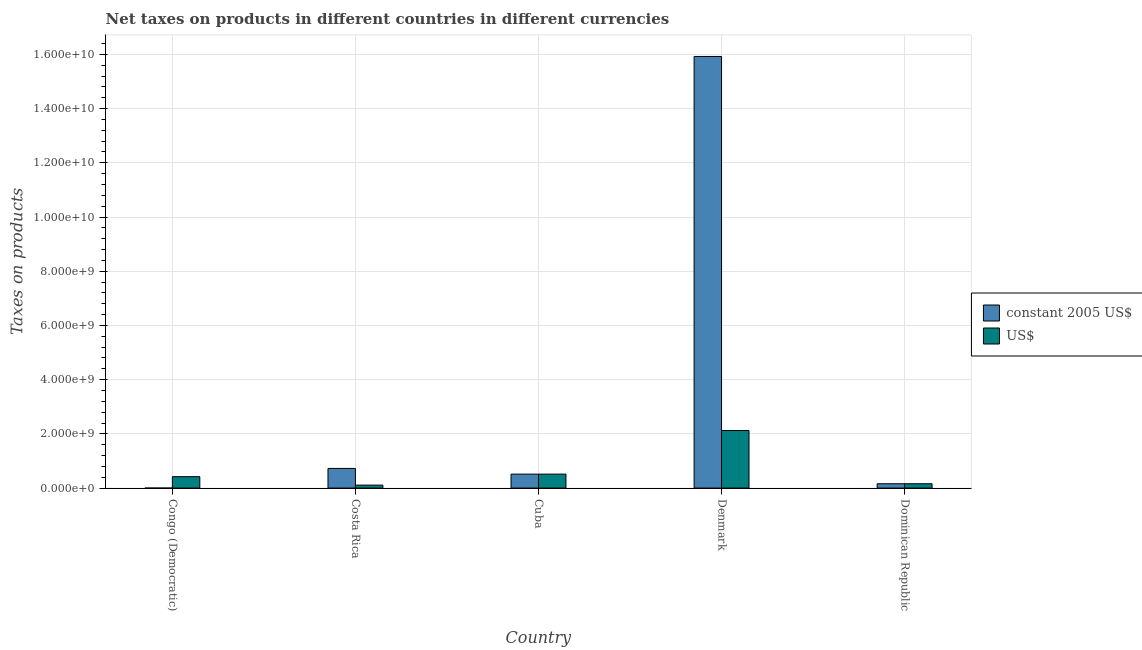What is the label of the 1st group of bars from the left?
Your response must be concise. Congo (Democratic). What is the net taxes in constant 2005 us$ in Denmark?
Offer a very short reply. 1.59e+1. Across all countries, what is the maximum net taxes in us$?
Your answer should be very brief. 2.12e+09. Across all countries, what is the minimum net taxes in us$?
Give a very brief answer. 1.09e+08. In which country was the net taxes in constant 2005 us$ maximum?
Offer a terse response. Denmark. What is the total net taxes in constant 2005 us$ in the graph?
Your answer should be very brief. 1.73e+1. What is the difference between the net taxes in constant 2005 us$ in Congo (Democratic) and that in Dominican Republic?
Offer a terse response. -1.60e+08. What is the difference between the net taxes in constant 2005 us$ in Denmark and the net taxes in us$ in Dominican Republic?
Keep it short and to the point. 1.58e+1. What is the average net taxes in constant 2005 us$ per country?
Ensure brevity in your answer.  3.47e+09. What is the difference between the net taxes in us$ and net taxes in constant 2005 us$ in Congo (Democratic)?
Provide a short and direct response. 4.22e+08. In how many countries, is the net taxes in us$ greater than 14800000000 units?
Provide a short and direct response. 0. What is the ratio of the net taxes in constant 2005 us$ in Congo (Democratic) to that in Costa Rica?
Your answer should be very brief. 9.713136937502124e-13. What is the difference between the highest and the second highest net taxes in us$?
Your answer should be compact. 1.61e+09. What is the difference between the highest and the lowest net taxes in constant 2005 us$?
Provide a succinct answer. 1.59e+1. In how many countries, is the net taxes in constant 2005 us$ greater than the average net taxes in constant 2005 us$ taken over all countries?
Keep it short and to the point. 1. What does the 2nd bar from the left in Cuba represents?
Give a very brief answer. US$. What does the 1st bar from the right in Cuba represents?
Offer a terse response. US$. Are all the bars in the graph horizontal?
Offer a terse response. No. What is the difference between two consecutive major ticks on the Y-axis?
Keep it short and to the point. 2.00e+09. Are the values on the major ticks of Y-axis written in scientific E-notation?
Keep it short and to the point. Yes. Where does the legend appear in the graph?
Keep it short and to the point. Center right. What is the title of the graph?
Your answer should be compact. Net taxes on products in different countries in different currencies. Does "External balance on goods" appear as one of the legend labels in the graph?
Offer a terse response. No. What is the label or title of the Y-axis?
Make the answer very short. Taxes on products. What is the Taxes on products in constant 2005 US$ in Congo (Democratic)?
Offer a terse response. 0. What is the Taxes on products in US$ in Congo (Democratic)?
Provide a succinct answer. 4.22e+08. What is the Taxes on products of constant 2005 US$ in Costa Rica?
Your answer should be very brief. 7.25e+08. What is the Taxes on products of US$ in Costa Rica?
Make the answer very short. 1.09e+08. What is the Taxes on products of constant 2005 US$ in Cuba?
Ensure brevity in your answer.  5.16e+08. What is the Taxes on products of US$ in Cuba?
Ensure brevity in your answer.  5.16e+08. What is the Taxes on products of constant 2005 US$ in Denmark?
Offer a very short reply. 1.59e+1. What is the Taxes on products in US$ in Denmark?
Offer a terse response. 2.12e+09. What is the Taxes on products of constant 2005 US$ in Dominican Republic?
Ensure brevity in your answer.  1.60e+08. What is the Taxes on products in US$ in Dominican Republic?
Your response must be concise. 1.60e+08. Across all countries, what is the maximum Taxes on products in constant 2005 US$?
Your answer should be compact. 1.59e+1. Across all countries, what is the maximum Taxes on products in US$?
Your answer should be very brief. 2.12e+09. Across all countries, what is the minimum Taxes on products in constant 2005 US$?
Your answer should be very brief. 0. Across all countries, what is the minimum Taxes on products in US$?
Your response must be concise. 1.09e+08. What is the total Taxes on products of constant 2005 US$ in the graph?
Offer a terse response. 1.73e+1. What is the total Taxes on products in US$ in the graph?
Provide a succinct answer. 3.33e+09. What is the difference between the Taxes on products in constant 2005 US$ in Congo (Democratic) and that in Costa Rica?
Your answer should be compact. -7.25e+08. What is the difference between the Taxes on products in US$ in Congo (Democratic) and that in Costa Rica?
Give a very brief answer. 3.12e+08. What is the difference between the Taxes on products of constant 2005 US$ in Congo (Democratic) and that in Cuba?
Give a very brief answer. -5.16e+08. What is the difference between the Taxes on products of US$ in Congo (Democratic) and that in Cuba?
Offer a terse response. -9.39e+07. What is the difference between the Taxes on products in constant 2005 US$ in Congo (Democratic) and that in Denmark?
Your answer should be very brief. -1.59e+1. What is the difference between the Taxes on products of US$ in Congo (Democratic) and that in Denmark?
Keep it short and to the point. -1.70e+09. What is the difference between the Taxes on products of constant 2005 US$ in Congo (Democratic) and that in Dominican Republic?
Make the answer very short. -1.60e+08. What is the difference between the Taxes on products in US$ in Congo (Democratic) and that in Dominican Republic?
Give a very brief answer. 2.62e+08. What is the difference between the Taxes on products of constant 2005 US$ in Costa Rica and that in Cuba?
Offer a very short reply. 2.10e+08. What is the difference between the Taxes on products of US$ in Costa Rica and that in Cuba?
Give a very brief answer. -4.06e+08. What is the difference between the Taxes on products of constant 2005 US$ in Costa Rica and that in Denmark?
Offer a very short reply. -1.52e+1. What is the difference between the Taxes on products of US$ in Costa Rica and that in Denmark?
Offer a terse response. -2.01e+09. What is the difference between the Taxes on products in constant 2005 US$ in Costa Rica and that in Dominican Republic?
Your response must be concise. 5.65e+08. What is the difference between the Taxes on products of US$ in Costa Rica and that in Dominican Republic?
Make the answer very short. -5.07e+07. What is the difference between the Taxes on products in constant 2005 US$ in Cuba and that in Denmark?
Offer a very short reply. -1.54e+1. What is the difference between the Taxes on products of US$ in Cuba and that in Denmark?
Provide a succinct answer. -1.61e+09. What is the difference between the Taxes on products of constant 2005 US$ in Cuba and that in Dominican Republic?
Keep it short and to the point. 3.55e+08. What is the difference between the Taxes on products in US$ in Cuba and that in Dominican Republic?
Keep it short and to the point. 3.55e+08. What is the difference between the Taxes on products in constant 2005 US$ in Denmark and that in Dominican Republic?
Provide a short and direct response. 1.58e+1. What is the difference between the Taxes on products in US$ in Denmark and that in Dominican Republic?
Your response must be concise. 1.96e+09. What is the difference between the Taxes on products in constant 2005 US$ in Congo (Democratic) and the Taxes on products in US$ in Costa Rica?
Provide a short and direct response. -1.09e+08. What is the difference between the Taxes on products of constant 2005 US$ in Congo (Democratic) and the Taxes on products of US$ in Cuba?
Provide a short and direct response. -5.16e+08. What is the difference between the Taxes on products in constant 2005 US$ in Congo (Democratic) and the Taxes on products in US$ in Denmark?
Make the answer very short. -2.12e+09. What is the difference between the Taxes on products in constant 2005 US$ in Congo (Democratic) and the Taxes on products in US$ in Dominican Republic?
Provide a short and direct response. -1.60e+08. What is the difference between the Taxes on products of constant 2005 US$ in Costa Rica and the Taxes on products of US$ in Cuba?
Keep it short and to the point. 2.10e+08. What is the difference between the Taxes on products of constant 2005 US$ in Costa Rica and the Taxes on products of US$ in Denmark?
Provide a short and direct response. -1.40e+09. What is the difference between the Taxes on products in constant 2005 US$ in Costa Rica and the Taxes on products in US$ in Dominican Republic?
Give a very brief answer. 5.65e+08. What is the difference between the Taxes on products of constant 2005 US$ in Cuba and the Taxes on products of US$ in Denmark?
Offer a very short reply. -1.61e+09. What is the difference between the Taxes on products of constant 2005 US$ in Cuba and the Taxes on products of US$ in Dominican Republic?
Your answer should be very brief. 3.55e+08. What is the difference between the Taxes on products in constant 2005 US$ in Denmark and the Taxes on products in US$ in Dominican Republic?
Ensure brevity in your answer.  1.58e+1. What is the average Taxes on products in constant 2005 US$ per country?
Offer a very short reply. 3.47e+09. What is the average Taxes on products of US$ per country?
Ensure brevity in your answer.  6.66e+08. What is the difference between the Taxes on products in constant 2005 US$ and Taxes on products in US$ in Congo (Democratic)?
Your response must be concise. -4.22e+08. What is the difference between the Taxes on products of constant 2005 US$ and Taxes on products of US$ in Costa Rica?
Provide a short and direct response. 6.16e+08. What is the difference between the Taxes on products in constant 2005 US$ and Taxes on products in US$ in Cuba?
Offer a very short reply. 0. What is the difference between the Taxes on products of constant 2005 US$ and Taxes on products of US$ in Denmark?
Offer a terse response. 1.38e+1. What is the ratio of the Taxes on products of US$ in Congo (Democratic) to that in Costa Rica?
Your answer should be compact. 3.85. What is the ratio of the Taxes on products in constant 2005 US$ in Congo (Democratic) to that in Cuba?
Give a very brief answer. 0. What is the ratio of the Taxes on products in US$ in Congo (Democratic) to that in Cuba?
Give a very brief answer. 0.82. What is the ratio of the Taxes on products of US$ in Congo (Democratic) to that in Denmark?
Ensure brevity in your answer.  0.2. What is the ratio of the Taxes on products of constant 2005 US$ in Congo (Democratic) to that in Dominican Republic?
Your response must be concise. 0. What is the ratio of the Taxes on products in US$ in Congo (Democratic) to that in Dominican Republic?
Give a very brief answer. 2.63. What is the ratio of the Taxes on products of constant 2005 US$ in Costa Rica to that in Cuba?
Your response must be concise. 1.41. What is the ratio of the Taxes on products of US$ in Costa Rica to that in Cuba?
Your response must be concise. 0.21. What is the ratio of the Taxes on products of constant 2005 US$ in Costa Rica to that in Denmark?
Ensure brevity in your answer.  0.05. What is the ratio of the Taxes on products in US$ in Costa Rica to that in Denmark?
Keep it short and to the point. 0.05. What is the ratio of the Taxes on products in constant 2005 US$ in Costa Rica to that in Dominican Republic?
Make the answer very short. 4.53. What is the ratio of the Taxes on products in US$ in Costa Rica to that in Dominican Republic?
Make the answer very short. 0.68. What is the ratio of the Taxes on products of constant 2005 US$ in Cuba to that in Denmark?
Your answer should be very brief. 0.03. What is the ratio of the Taxes on products in US$ in Cuba to that in Denmark?
Offer a terse response. 0.24. What is the ratio of the Taxes on products in constant 2005 US$ in Cuba to that in Dominican Republic?
Give a very brief answer. 3.22. What is the ratio of the Taxes on products in US$ in Cuba to that in Dominican Republic?
Provide a short and direct response. 3.22. What is the ratio of the Taxes on products of constant 2005 US$ in Denmark to that in Dominican Republic?
Provide a short and direct response. 99.41. What is the ratio of the Taxes on products of US$ in Denmark to that in Dominican Republic?
Make the answer very short. 13.25. What is the difference between the highest and the second highest Taxes on products of constant 2005 US$?
Your answer should be very brief. 1.52e+1. What is the difference between the highest and the second highest Taxes on products in US$?
Offer a terse response. 1.61e+09. What is the difference between the highest and the lowest Taxes on products in constant 2005 US$?
Your response must be concise. 1.59e+1. What is the difference between the highest and the lowest Taxes on products of US$?
Offer a terse response. 2.01e+09. 